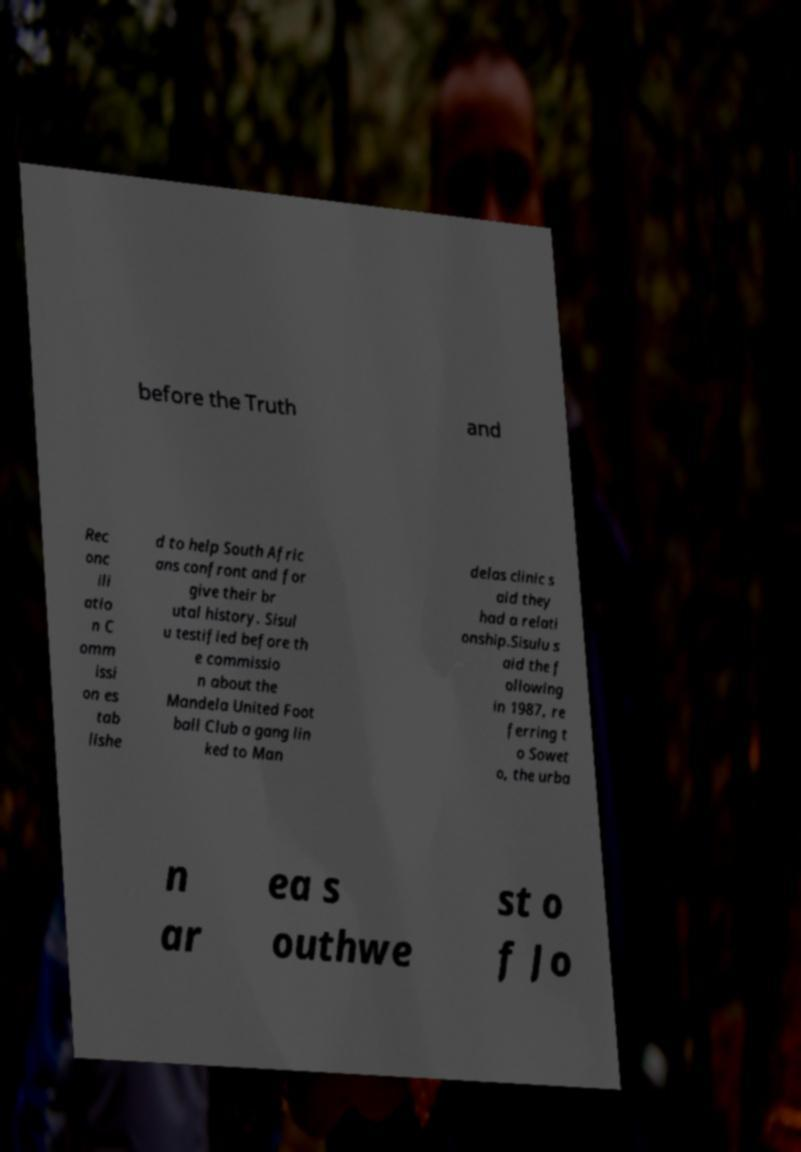For documentation purposes, I need the text within this image transcribed. Could you provide that? before the Truth and Rec onc ili atio n C omm issi on es tab lishe d to help South Afric ans confront and for give their br utal history. Sisul u testified before th e commissio n about the Mandela United Foot ball Club a gang lin ked to Man delas clinic s aid they had a relati onship.Sisulu s aid the f ollowing in 1987, re ferring t o Sowet o, the urba n ar ea s outhwe st o f Jo 